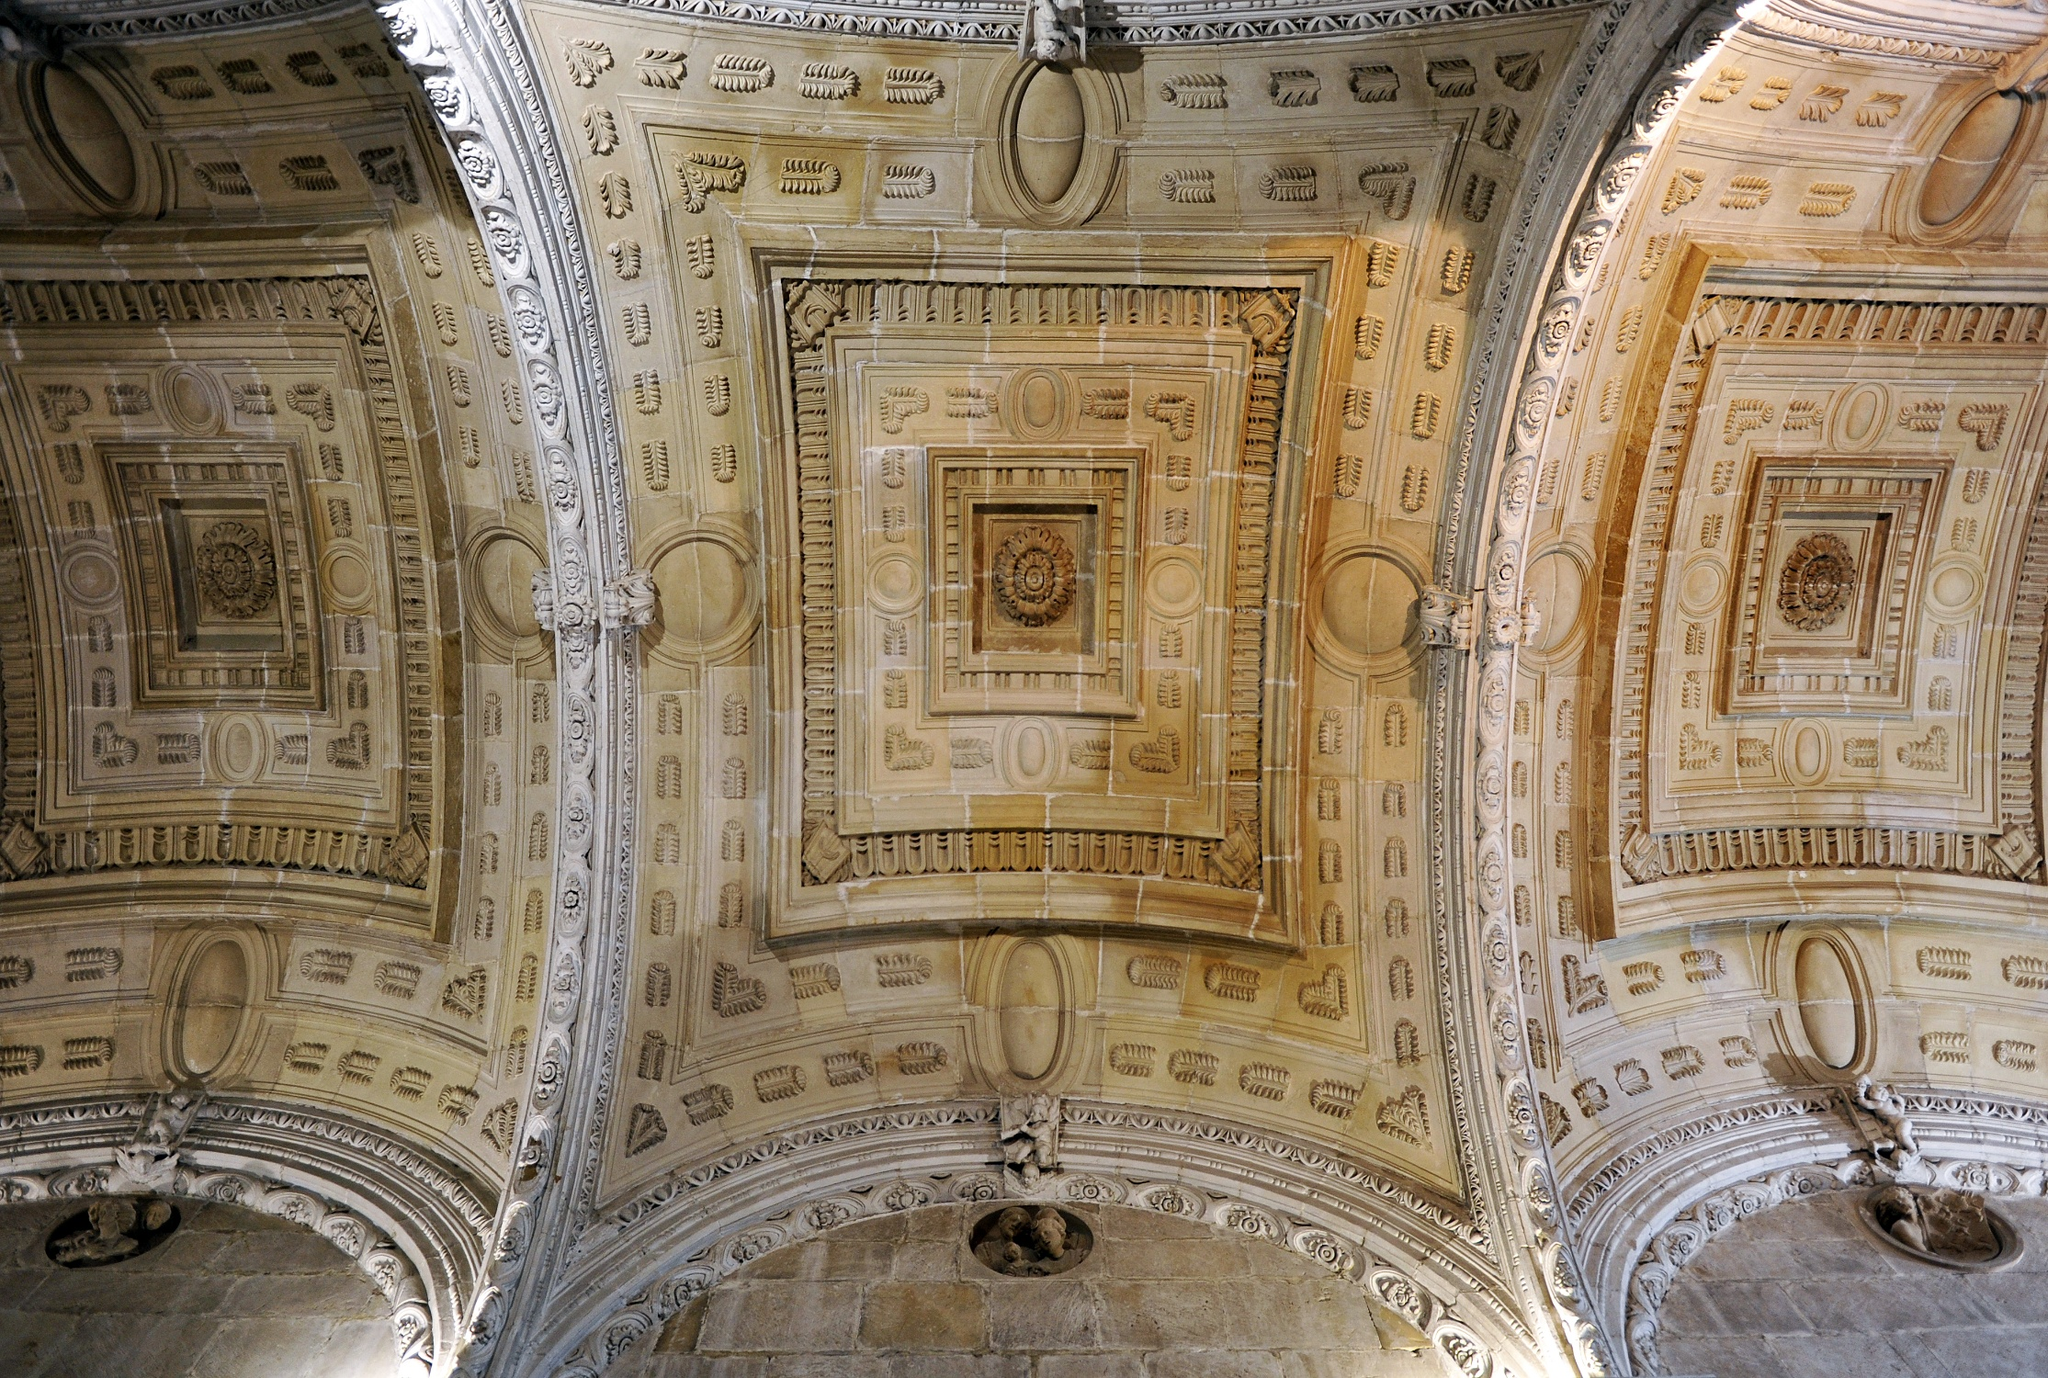Can you describe the details and possible historical context of this ceiling? The ceiling in the image is adorned with intricate geometric and floral designs, reflecting a meticulous approach to architectural decoration. The use of repeating patterns suggests influences from Renaissance or Baroque styles, where symmetry and detail were highly prized. This type of ceiling would typically be found in a grand hall or place of worship, suggesting that the building it belongs to was of significant importance. The decorative elements, such as the rosettes and acanthus leaves, are classical motifs often used in European architecture. This ceiling likely served not only an aesthetic purpose but also symbolized the wealth and cultural sophistication of its patrons. 